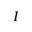<formula> <loc_0><loc_0><loc_500><loc_500>I</formula> 